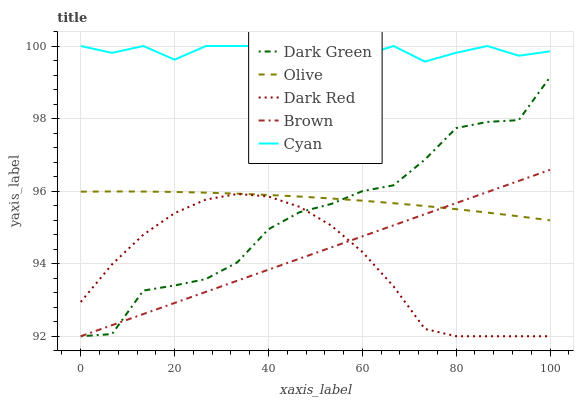Does Cyan have the minimum area under the curve?
Answer yes or no. No. Does Dark Red have the maximum area under the curve?
Answer yes or no. No. Is Dark Red the smoothest?
Answer yes or no. No. Is Dark Red the roughest?
Answer yes or no. No. Does Cyan have the lowest value?
Answer yes or no. No. Does Dark Red have the highest value?
Answer yes or no. No. Is Dark Red less than Cyan?
Answer yes or no. Yes. Is Cyan greater than Brown?
Answer yes or no. Yes. Does Dark Red intersect Cyan?
Answer yes or no. No. 